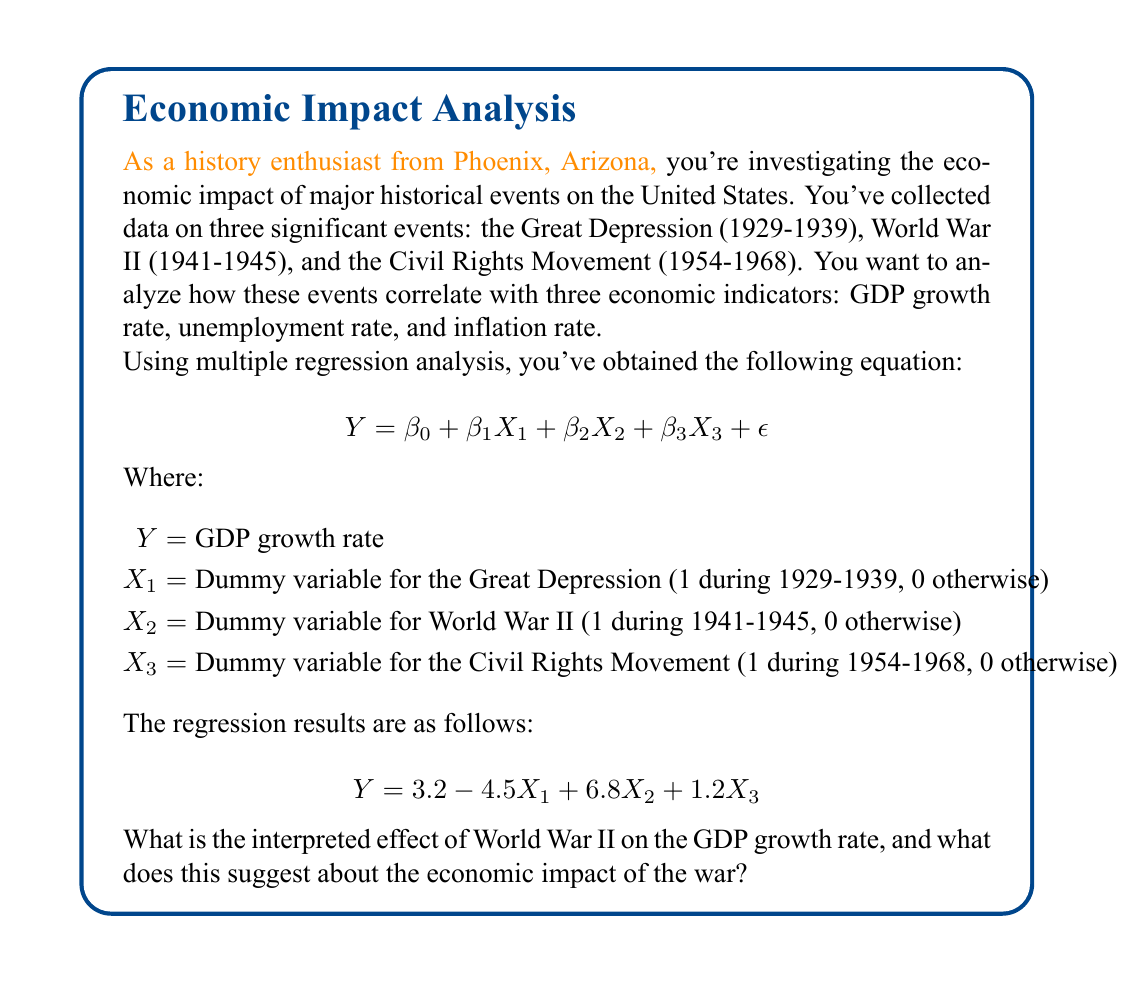Teach me how to tackle this problem. To interpret the effect of World War II on the GDP growth rate, we need to focus on the coefficient of $X_2$ in the regression equation. Let's break down the interpretation step-by-step:

1. Identify the coefficient: The coefficient for $X_2$ (World War II) is 6.8.

2. Interpret the coefficient: In a multiple regression with dummy variables, the coefficient represents the average change in the dependent variable when the dummy variable equals 1, holding all other variables constant.

3. Apply to our context: The coefficient of 6.8 for $X_2$ means that, on average, during the years of World War II (1941-1945), the GDP growth rate was 6.8 percentage points higher than in non-war years, holding the effects of the Great Depression and Civil Rights Movement constant.

4. Economic interpretation: This suggests that World War II had a significant positive impact on the U.S. economy in terms of GDP growth. This aligns with historical accounts of increased industrial production, employment, and overall economic activity during the war years.

5. Comparison with other events: The coefficient for World War II (6.8) is larger in magnitude than those for the Great Depression (-4.5) and the Civil Rights Movement (1.2), indicating that among these three events, World War II had the strongest correlation with GDP growth.

6. Causal interpretation caution: While this regression shows a strong positive correlation between World War II and GDP growth, it's important to note that correlation doesn't necessarily imply causation. Other factors not included in this model could also have influenced GDP growth during this period.

In summary, the regression results suggest that World War II was associated with a significant boost to the U.S. economy, with an average increase in GDP growth rate of 6.8 percentage points during the war years compared to non-war years.
Answer: World War II is associated with a 6.8 percentage point increase in GDP growth rate, suggesting a significant positive economic impact. 